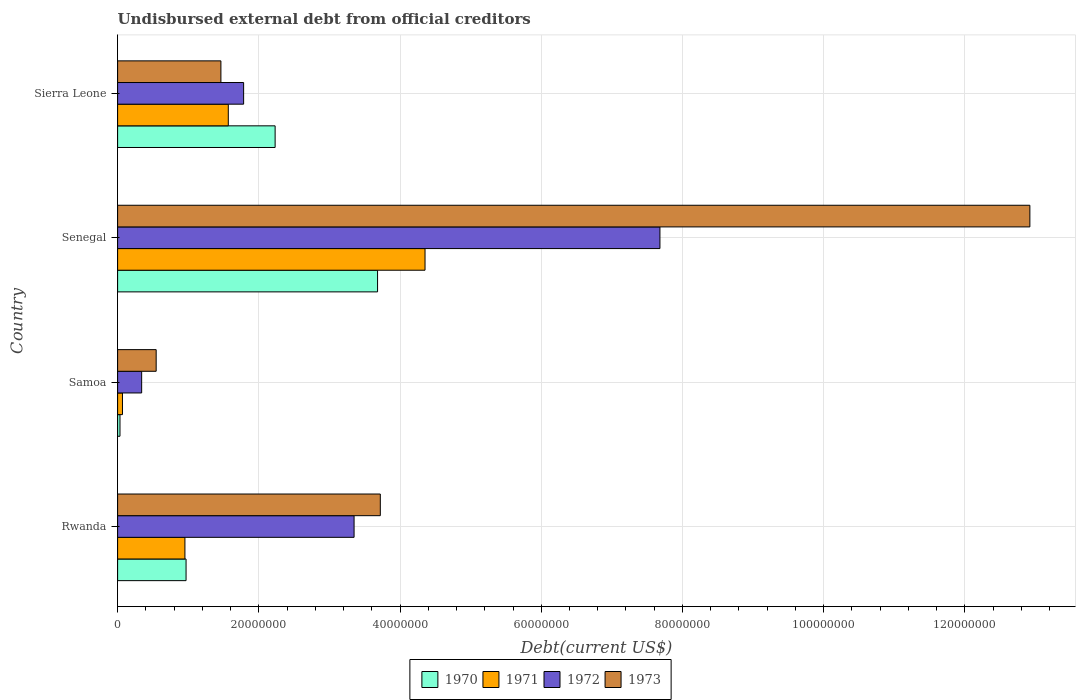How many groups of bars are there?
Make the answer very short. 4. How many bars are there on the 3rd tick from the top?
Keep it short and to the point. 4. How many bars are there on the 3rd tick from the bottom?
Ensure brevity in your answer.  4. What is the label of the 2nd group of bars from the top?
Provide a succinct answer. Senegal. What is the total debt in 1972 in Samoa?
Give a very brief answer. 3.40e+06. Across all countries, what is the maximum total debt in 1971?
Ensure brevity in your answer.  4.35e+07. Across all countries, what is the minimum total debt in 1971?
Ensure brevity in your answer.  6.88e+05. In which country was the total debt in 1972 maximum?
Your response must be concise. Senegal. In which country was the total debt in 1970 minimum?
Keep it short and to the point. Samoa. What is the total total debt in 1970 in the graph?
Keep it short and to the point. 6.92e+07. What is the difference between the total debt in 1973 in Rwanda and that in Samoa?
Give a very brief answer. 3.17e+07. What is the difference between the total debt in 1971 in Senegal and the total debt in 1970 in Samoa?
Provide a short and direct response. 4.32e+07. What is the average total debt in 1971 per country?
Offer a very short reply. 1.74e+07. What is the difference between the total debt in 1971 and total debt in 1972 in Rwanda?
Your response must be concise. -2.40e+07. In how many countries, is the total debt in 1972 greater than 76000000 US$?
Keep it short and to the point. 1. What is the ratio of the total debt in 1970 in Senegal to that in Sierra Leone?
Offer a very short reply. 1.65. Is the total debt in 1970 in Rwanda less than that in Sierra Leone?
Your answer should be very brief. Yes. What is the difference between the highest and the second highest total debt in 1972?
Keep it short and to the point. 4.33e+07. What is the difference between the highest and the lowest total debt in 1971?
Keep it short and to the point. 4.29e+07. Is the sum of the total debt in 1971 in Senegal and Sierra Leone greater than the maximum total debt in 1972 across all countries?
Ensure brevity in your answer.  No. Is it the case that in every country, the sum of the total debt in 1970 and total debt in 1971 is greater than the sum of total debt in 1973 and total debt in 1972?
Offer a terse response. No. What does the 2nd bar from the top in Rwanda represents?
Provide a short and direct response. 1972. Is it the case that in every country, the sum of the total debt in 1972 and total debt in 1971 is greater than the total debt in 1970?
Keep it short and to the point. Yes. Are all the bars in the graph horizontal?
Offer a terse response. Yes. How many countries are there in the graph?
Offer a very short reply. 4. What is the difference between two consecutive major ticks on the X-axis?
Your answer should be compact. 2.00e+07. Are the values on the major ticks of X-axis written in scientific E-notation?
Your answer should be compact. No. How many legend labels are there?
Keep it short and to the point. 4. How are the legend labels stacked?
Your answer should be compact. Horizontal. What is the title of the graph?
Give a very brief answer. Undisbursed external debt from official creditors. Does "1998" appear as one of the legend labels in the graph?
Provide a succinct answer. No. What is the label or title of the X-axis?
Your response must be concise. Debt(current US$). What is the label or title of the Y-axis?
Your answer should be very brief. Country. What is the Debt(current US$) in 1970 in Rwanda?
Offer a terse response. 9.70e+06. What is the Debt(current US$) in 1971 in Rwanda?
Your answer should be very brief. 9.53e+06. What is the Debt(current US$) of 1972 in Rwanda?
Ensure brevity in your answer.  3.35e+07. What is the Debt(current US$) of 1973 in Rwanda?
Keep it short and to the point. 3.72e+07. What is the Debt(current US$) of 1970 in Samoa?
Provide a succinct answer. 3.36e+05. What is the Debt(current US$) in 1971 in Samoa?
Offer a very short reply. 6.88e+05. What is the Debt(current US$) in 1972 in Samoa?
Offer a very short reply. 3.40e+06. What is the Debt(current US$) in 1973 in Samoa?
Provide a succinct answer. 5.46e+06. What is the Debt(current US$) of 1970 in Senegal?
Offer a very short reply. 3.68e+07. What is the Debt(current US$) of 1971 in Senegal?
Provide a short and direct response. 4.35e+07. What is the Debt(current US$) in 1972 in Senegal?
Keep it short and to the point. 7.68e+07. What is the Debt(current US$) of 1973 in Senegal?
Offer a very short reply. 1.29e+08. What is the Debt(current US$) of 1970 in Sierra Leone?
Offer a terse response. 2.23e+07. What is the Debt(current US$) of 1971 in Sierra Leone?
Keep it short and to the point. 1.57e+07. What is the Debt(current US$) in 1972 in Sierra Leone?
Provide a succinct answer. 1.78e+07. What is the Debt(current US$) of 1973 in Sierra Leone?
Your response must be concise. 1.46e+07. Across all countries, what is the maximum Debt(current US$) of 1970?
Ensure brevity in your answer.  3.68e+07. Across all countries, what is the maximum Debt(current US$) of 1971?
Your answer should be compact. 4.35e+07. Across all countries, what is the maximum Debt(current US$) of 1972?
Your answer should be very brief. 7.68e+07. Across all countries, what is the maximum Debt(current US$) in 1973?
Provide a short and direct response. 1.29e+08. Across all countries, what is the minimum Debt(current US$) of 1970?
Offer a terse response. 3.36e+05. Across all countries, what is the minimum Debt(current US$) in 1971?
Offer a very short reply. 6.88e+05. Across all countries, what is the minimum Debt(current US$) in 1972?
Provide a succinct answer. 3.40e+06. Across all countries, what is the minimum Debt(current US$) of 1973?
Ensure brevity in your answer.  5.46e+06. What is the total Debt(current US$) of 1970 in the graph?
Give a very brief answer. 6.92e+07. What is the total Debt(current US$) of 1971 in the graph?
Your answer should be compact. 6.94e+07. What is the total Debt(current US$) of 1972 in the graph?
Your answer should be compact. 1.32e+08. What is the total Debt(current US$) in 1973 in the graph?
Provide a short and direct response. 1.87e+08. What is the difference between the Debt(current US$) in 1970 in Rwanda and that in Samoa?
Provide a short and direct response. 9.36e+06. What is the difference between the Debt(current US$) in 1971 in Rwanda and that in Samoa?
Keep it short and to the point. 8.84e+06. What is the difference between the Debt(current US$) in 1972 in Rwanda and that in Samoa?
Offer a terse response. 3.01e+07. What is the difference between the Debt(current US$) in 1973 in Rwanda and that in Samoa?
Provide a succinct answer. 3.17e+07. What is the difference between the Debt(current US$) of 1970 in Rwanda and that in Senegal?
Provide a short and direct response. -2.71e+07. What is the difference between the Debt(current US$) in 1971 in Rwanda and that in Senegal?
Your answer should be very brief. -3.40e+07. What is the difference between the Debt(current US$) of 1972 in Rwanda and that in Senegal?
Keep it short and to the point. -4.33e+07. What is the difference between the Debt(current US$) of 1973 in Rwanda and that in Senegal?
Provide a short and direct response. -9.20e+07. What is the difference between the Debt(current US$) in 1970 in Rwanda and that in Sierra Leone?
Make the answer very short. -1.26e+07. What is the difference between the Debt(current US$) of 1971 in Rwanda and that in Sierra Leone?
Offer a terse response. -6.14e+06. What is the difference between the Debt(current US$) of 1972 in Rwanda and that in Sierra Leone?
Provide a short and direct response. 1.56e+07. What is the difference between the Debt(current US$) in 1973 in Rwanda and that in Sierra Leone?
Offer a terse response. 2.26e+07. What is the difference between the Debt(current US$) in 1970 in Samoa and that in Senegal?
Your answer should be very brief. -3.65e+07. What is the difference between the Debt(current US$) in 1971 in Samoa and that in Senegal?
Your response must be concise. -4.29e+07. What is the difference between the Debt(current US$) of 1972 in Samoa and that in Senegal?
Provide a short and direct response. -7.34e+07. What is the difference between the Debt(current US$) in 1973 in Samoa and that in Senegal?
Ensure brevity in your answer.  -1.24e+08. What is the difference between the Debt(current US$) in 1970 in Samoa and that in Sierra Leone?
Offer a very short reply. -2.20e+07. What is the difference between the Debt(current US$) in 1971 in Samoa and that in Sierra Leone?
Ensure brevity in your answer.  -1.50e+07. What is the difference between the Debt(current US$) in 1972 in Samoa and that in Sierra Leone?
Provide a succinct answer. -1.44e+07. What is the difference between the Debt(current US$) in 1973 in Samoa and that in Sierra Leone?
Provide a short and direct response. -9.17e+06. What is the difference between the Debt(current US$) in 1970 in Senegal and that in Sierra Leone?
Your answer should be compact. 1.45e+07. What is the difference between the Debt(current US$) of 1971 in Senegal and that in Sierra Leone?
Keep it short and to the point. 2.79e+07. What is the difference between the Debt(current US$) of 1972 in Senegal and that in Sierra Leone?
Give a very brief answer. 5.90e+07. What is the difference between the Debt(current US$) of 1973 in Senegal and that in Sierra Leone?
Give a very brief answer. 1.15e+08. What is the difference between the Debt(current US$) of 1970 in Rwanda and the Debt(current US$) of 1971 in Samoa?
Ensure brevity in your answer.  9.01e+06. What is the difference between the Debt(current US$) in 1970 in Rwanda and the Debt(current US$) in 1972 in Samoa?
Make the answer very short. 6.29e+06. What is the difference between the Debt(current US$) in 1970 in Rwanda and the Debt(current US$) in 1973 in Samoa?
Keep it short and to the point. 4.23e+06. What is the difference between the Debt(current US$) of 1971 in Rwanda and the Debt(current US$) of 1972 in Samoa?
Ensure brevity in your answer.  6.13e+06. What is the difference between the Debt(current US$) in 1971 in Rwanda and the Debt(current US$) in 1973 in Samoa?
Offer a terse response. 4.07e+06. What is the difference between the Debt(current US$) in 1972 in Rwanda and the Debt(current US$) in 1973 in Samoa?
Your answer should be compact. 2.80e+07. What is the difference between the Debt(current US$) of 1970 in Rwanda and the Debt(current US$) of 1971 in Senegal?
Offer a very short reply. -3.38e+07. What is the difference between the Debt(current US$) in 1970 in Rwanda and the Debt(current US$) in 1972 in Senegal?
Ensure brevity in your answer.  -6.71e+07. What is the difference between the Debt(current US$) of 1970 in Rwanda and the Debt(current US$) of 1973 in Senegal?
Your response must be concise. -1.20e+08. What is the difference between the Debt(current US$) in 1971 in Rwanda and the Debt(current US$) in 1972 in Senegal?
Give a very brief answer. -6.73e+07. What is the difference between the Debt(current US$) of 1971 in Rwanda and the Debt(current US$) of 1973 in Senegal?
Ensure brevity in your answer.  -1.20e+08. What is the difference between the Debt(current US$) of 1972 in Rwanda and the Debt(current US$) of 1973 in Senegal?
Offer a terse response. -9.57e+07. What is the difference between the Debt(current US$) in 1970 in Rwanda and the Debt(current US$) in 1971 in Sierra Leone?
Ensure brevity in your answer.  -5.98e+06. What is the difference between the Debt(current US$) in 1970 in Rwanda and the Debt(current US$) in 1972 in Sierra Leone?
Offer a very short reply. -8.15e+06. What is the difference between the Debt(current US$) of 1970 in Rwanda and the Debt(current US$) of 1973 in Sierra Leone?
Make the answer very short. -4.93e+06. What is the difference between the Debt(current US$) of 1971 in Rwanda and the Debt(current US$) of 1972 in Sierra Leone?
Offer a very short reply. -8.32e+06. What is the difference between the Debt(current US$) of 1971 in Rwanda and the Debt(current US$) of 1973 in Sierra Leone?
Your answer should be compact. -5.10e+06. What is the difference between the Debt(current US$) in 1972 in Rwanda and the Debt(current US$) in 1973 in Sierra Leone?
Provide a short and direct response. 1.89e+07. What is the difference between the Debt(current US$) of 1970 in Samoa and the Debt(current US$) of 1971 in Senegal?
Provide a succinct answer. -4.32e+07. What is the difference between the Debt(current US$) in 1970 in Samoa and the Debt(current US$) in 1972 in Senegal?
Your answer should be very brief. -7.65e+07. What is the difference between the Debt(current US$) of 1970 in Samoa and the Debt(current US$) of 1973 in Senegal?
Keep it short and to the point. -1.29e+08. What is the difference between the Debt(current US$) in 1971 in Samoa and the Debt(current US$) in 1972 in Senegal?
Ensure brevity in your answer.  -7.61e+07. What is the difference between the Debt(current US$) of 1971 in Samoa and the Debt(current US$) of 1973 in Senegal?
Provide a short and direct response. -1.29e+08. What is the difference between the Debt(current US$) of 1972 in Samoa and the Debt(current US$) of 1973 in Senegal?
Your answer should be compact. -1.26e+08. What is the difference between the Debt(current US$) of 1970 in Samoa and the Debt(current US$) of 1971 in Sierra Leone?
Your answer should be compact. -1.53e+07. What is the difference between the Debt(current US$) in 1970 in Samoa and the Debt(current US$) in 1972 in Sierra Leone?
Ensure brevity in your answer.  -1.75e+07. What is the difference between the Debt(current US$) in 1970 in Samoa and the Debt(current US$) in 1973 in Sierra Leone?
Provide a succinct answer. -1.43e+07. What is the difference between the Debt(current US$) of 1971 in Samoa and the Debt(current US$) of 1972 in Sierra Leone?
Your answer should be very brief. -1.72e+07. What is the difference between the Debt(current US$) of 1971 in Samoa and the Debt(current US$) of 1973 in Sierra Leone?
Make the answer very short. -1.39e+07. What is the difference between the Debt(current US$) of 1972 in Samoa and the Debt(current US$) of 1973 in Sierra Leone?
Give a very brief answer. -1.12e+07. What is the difference between the Debt(current US$) of 1970 in Senegal and the Debt(current US$) of 1971 in Sierra Leone?
Provide a short and direct response. 2.11e+07. What is the difference between the Debt(current US$) of 1970 in Senegal and the Debt(current US$) of 1972 in Sierra Leone?
Ensure brevity in your answer.  1.90e+07. What is the difference between the Debt(current US$) in 1970 in Senegal and the Debt(current US$) in 1973 in Sierra Leone?
Give a very brief answer. 2.22e+07. What is the difference between the Debt(current US$) in 1971 in Senegal and the Debt(current US$) in 1972 in Sierra Leone?
Offer a very short reply. 2.57e+07. What is the difference between the Debt(current US$) in 1971 in Senegal and the Debt(current US$) in 1973 in Sierra Leone?
Make the answer very short. 2.89e+07. What is the difference between the Debt(current US$) in 1972 in Senegal and the Debt(current US$) in 1973 in Sierra Leone?
Offer a very short reply. 6.22e+07. What is the average Debt(current US$) in 1970 per country?
Your response must be concise. 1.73e+07. What is the average Debt(current US$) of 1971 per country?
Your answer should be very brief. 1.74e+07. What is the average Debt(current US$) of 1972 per country?
Offer a very short reply. 3.29e+07. What is the average Debt(current US$) of 1973 per country?
Keep it short and to the point. 4.66e+07. What is the difference between the Debt(current US$) in 1970 and Debt(current US$) in 1971 in Rwanda?
Give a very brief answer. 1.63e+05. What is the difference between the Debt(current US$) in 1970 and Debt(current US$) in 1972 in Rwanda?
Your answer should be very brief. -2.38e+07. What is the difference between the Debt(current US$) of 1970 and Debt(current US$) of 1973 in Rwanda?
Keep it short and to the point. -2.75e+07. What is the difference between the Debt(current US$) in 1971 and Debt(current US$) in 1972 in Rwanda?
Your response must be concise. -2.40e+07. What is the difference between the Debt(current US$) of 1971 and Debt(current US$) of 1973 in Rwanda?
Your response must be concise. -2.77e+07. What is the difference between the Debt(current US$) in 1972 and Debt(current US$) in 1973 in Rwanda?
Provide a succinct answer. -3.72e+06. What is the difference between the Debt(current US$) in 1970 and Debt(current US$) in 1971 in Samoa?
Your answer should be very brief. -3.52e+05. What is the difference between the Debt(current US$) of 1970 and Debt(current US$) of 1972 in Samoa?
Provide a succinct answer. -3.07e+06. What is the difference between the Debt(current US$) of 1970 and Debt(current US$) of 1973 in Samoa?
Your answer should be very brief. -5.13e+06. What is the difference between the Debt(current US$) of 1971 and Debt(current US$) of 1972 in Samoa?
Keep it short and to the point. -2.72e+06. What is the difference between the Debt(current US$) in 1971 and Debt(current US$) in 1973 in Samoa?
Your response must be concise. -4.77e+06. What is the difference between the Debt(current US$) of 1972 and Debt(current US$) of 1973 in Samoa?
Your answer should be very brief. -2.06e+06. What is the difference between the Debt(current US$) of 1970 and Debt(current US$) of 1971 in Senegal?
Give a very brief answer. -6.72e+06. What is the difference between the Debt(current US$) in 1970 and Debt(current US$) in 1972 in Senegal?
Give a very brief answer. -4.00e+07. What is the difference between the Debt(current US$) in 1970 and Debt(current US$) in 1973 in Senegal?
Offer a very short reply. -9.24e+07. What is the difference between the Debt(current US$) of 1971 and Debt(current US$) of 1972 in Senegal?
Ensure brevity in your answer.  -3.33e+07. What is the difference between the Debt(current US$) of 1971 and Debt(current US$) of 1973 in Senegal?
Give a very brief answer. -8.57e+07. What is the difference between the Debt(current US$) in 1972 and Debt(current US$) in 1973 in Senegal?
Provide a succinct answer. -5.24e+07. What is the difference between the Debt(current US$) of 1970 and Debt(current US$) of 1971 in Sierra Leone?
Make the answer very short. 6.63e+06. What is the difference between the Debt(current US$) of 1970 and Debt(current US$) of 1972 in Sierra Leone?
Ensure brevity in your answer.  4.46e+06. What is the difference between the Debt(current US$) in 1970 and Debt(current US$) in 1973 in Sierra Leone?
Provide a succinct answer. 7.68e+06. What is the difference between the Debt(current US$) of 1971 and Debt(current US$) of 1972 in Sierra Leone?
Your response must be concise. -2.17e+06. What is the difference between the Debt(current US$) in 1971 and Debt(current US$) in 1973 in Sierra Leone?
Give a very brief answer. 1.05e+06. What is the difference between the Debt(current US$) in 1972 and Debt(current US$) in 1973 in Sierra Leone?
Make the answer very short. 3.22e+06. What is the ratio of the Debt(current US$) in 1970 in Rwanda to that in Samoa?
Your response must be concise. 28.86. What is the ratio of the Debt(current US$) in 1971 in Rwanda to that in Samoa?
Make the answer very short. 13.86. What is the ratio of the Debt(current US$) of 1972 in Rwanda to that in Samoa?
Provide a succinct answer. 9.84. What is the ratio of the Debt(current US$) of 1973 in Rwanda to that in Samoa?
Your answer should be very brief. 6.81. What is the ratio of the Debt(current US$) of 1970 in Rwanda to that in Senegal?
Offer a very short reply. 0.26. What is the ratio of the Debt(current US$) in 1971 in Rwanda to that in Senegal?
Your answer should be compact. 0.22. What is the ratio of the Debt(current US$) in 1972 in Rwanda to that in Senegal?
Provide a short and direct response. 0.44. What is the ratio of the Debt(current US$) in 1973 in Rwanda to that in Senegal?
Keep it short and to the point. 0.29. What is the ratio of the Debt(current US$) in 1970 in Rwanda to that in Sierra Leone?
Provide a short and direct response. 0.43. What is the ratio of the Debt(current US$) in 1971 in Rwanda to that in Sierra Leone?
Keep it short and to the point. 0.61. What is the ratio of the Debt(current US$) of 1972 in Rwanda to that in Sierra Leone?
Your response must be concise. 1.88. What is the ratio of the Debt(current US$) of 1973 in Rwanda to that in Sierra Leone?
Offer a terse response. 2.54. What is the ratio of the Debt(current US$) in 1970 in Samoa to that in Senegal?
Your answer should be compact. 0.01. What is the ratio of the Debt(current US$) in 1971 in Samoa to that in Senegal?
Make the answer very short. 0.02. What is the ratio of the Debt(current US$) in 1972 in Samoa to that in Senegal?
Your answer should be very brief. 0.04. What is the ratio of the Debt(current US$) of 1973 in Samoa to that in Senegal?
Keep it short and to the point. 0.04. What is the ratio of the Debt(current US$) of 1970 in Samoa to that in Sierra Leone?
Your response must be concise. 0.02. What is the ratio of the Debt(current US$) of 1971 in Samoa to that in Sierra Leone?
Make the answer very short. 0.04. What is the ratio of the Debt(current US$) of 1972 in Samoa to that in Sierra Leone?
Make the answer very short. 0.19. What is the ratio of the Debt(current US$) in 1973 in Samoa to that in Sierra Leone?
Give a very brief answer. 0.37. What is the ratio of the Debt(current US$) of 1970 in Senegal to that in Sierra Leone?
Your answer should be very brief. 1.65. What is the ratio of the Debt(current US$) of 1971 in Senegal to that in Sierra Leone?
Keep it short and to the point. 2.78. What is the ratio of the Debt(current US$) in 1972 in Senegal to that in Sierra Leone?
Give a very brief answer. 4.3. What is the ratio of the Debt(current US$) in 1973 in Senegal to that in Sierra Leone?
Your answer should be very brief. 8.83. What is the difference between the highest and the second highest Debt(current US$) in 1970?
Your response must be concise. 1.45e+07. What is the difference between the highest and the second highest Debt(current US$) in 1971?
Your answer should be very brief. 2.79e+07. What is the difference between the highest and the second highest Debt(current US$) in 1972?
Your answer should be very brief. 4.33e+07. What is the difference between the highest and the second highest Debt(current US$) of 1973?
Keep it short and to the point. 9.20e+07. What is the difference between the highest and the lowest Debt(current US$) in 1970?
Keep it short and to the point. 3.65e+07. What is the difference between the highest and the lowest Debt(current US$) of 1971?
Offer a very short reply. 4.29e+07. What is the difference between the highest and the lowest Debt(current US$) of 1972?
Offer a terse response. 7.34e+07. What is the difference between the highest and the lowest Debt(current US$) of 1973?
Ensure brevity in your answer.  1.24e+08. 